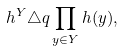<formula> <loc_0><loc_0><loc_500><loc_500>h ^ { Y } \triangle q \prod _ { y \in Y } h ( y ) ,</formula> 